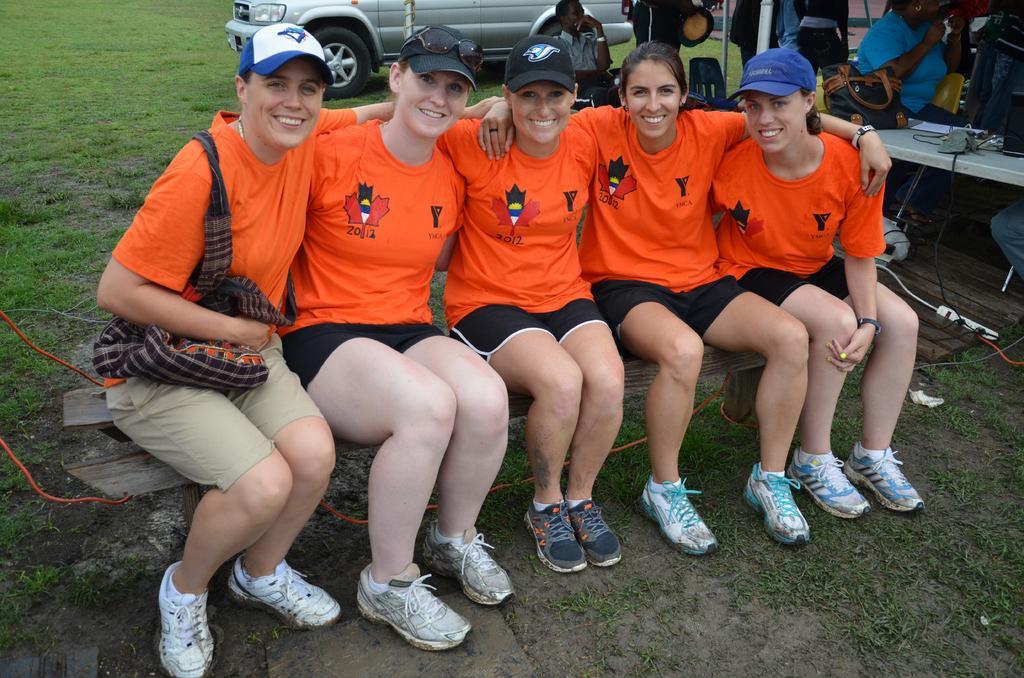Please provide a concise description of this image. In this picture there are people, those who are sitting in series on the bench, in the center of the image, there is a car at the top side of the image, there are other people in the top right side of the image. 